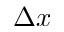Convert formula to latex. <formula><loc_0><loc_0><loc_500><loc_500>\Delta x</formula> 